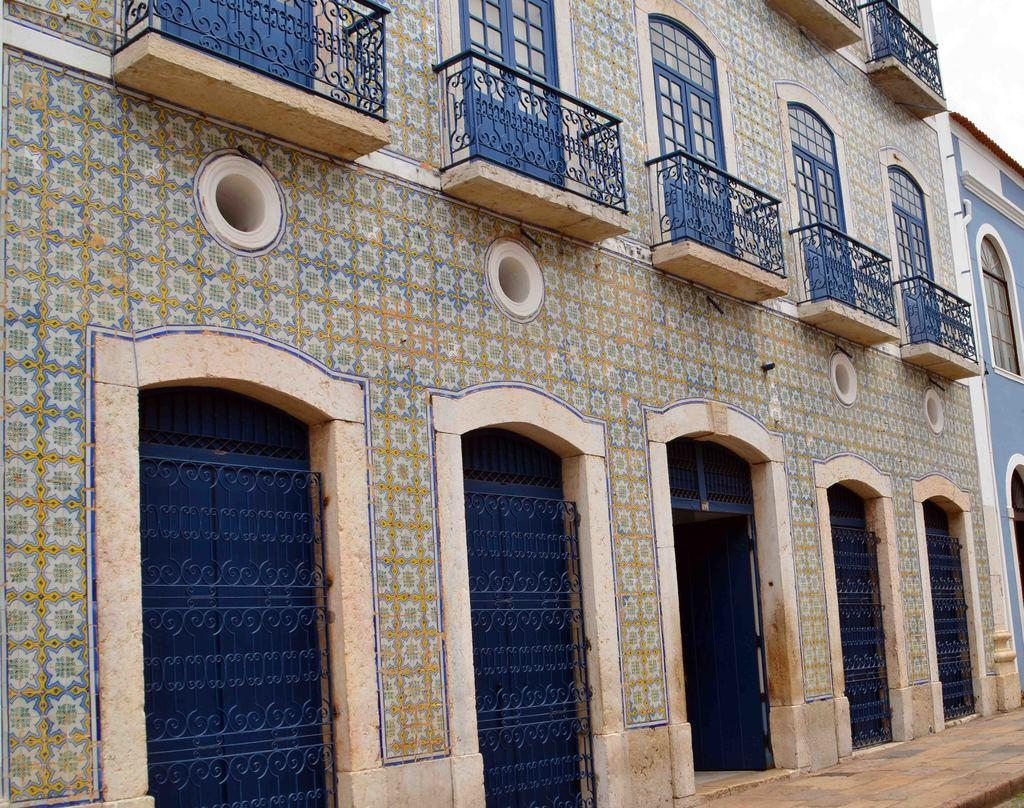What type of structure is present in the image? There is a building in the picture. What features can be seen on the building? The building has doors and balconies. What type of act is being performed on the balcony in the image? There is no act being performed on the balcony in the image, as it only shows the building's structure. 